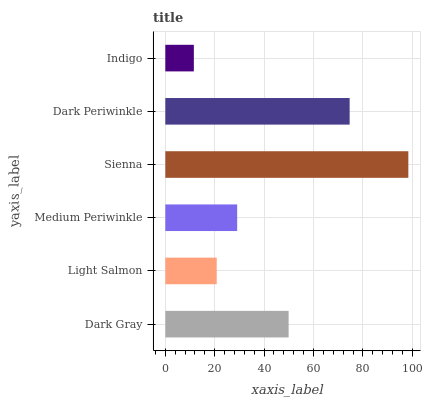Is Indigo the minimum?
Answer yes or no. Yes. Is Sienna the maximum?
Answer yes or no. Yes. Is Light Salmon the minimum?
Answer yes or no. No. Is Light Salmon the maximum?
Answer yes or no. No. Is Dark Gray greater than Light Salmon?
Answer yes or no. Yes. Is Light Salmon less than Dark Gray?
Answer yes or no. Yes. Is Light Salmon greater than Dark Gray?
Answer yes or no. No. Is Dark Gray less than Light Salmon?
Answer yes or no. No. Is Dark Gray the high median?
Answer yes or no. Yes. Is Medium Periwinkle the low median?
Answer yes or no. Yes. Is Medium Periwinkle the high median?
Answer yes or no. No. Is Dark Gray the low median?
Answer yes or no. No. 